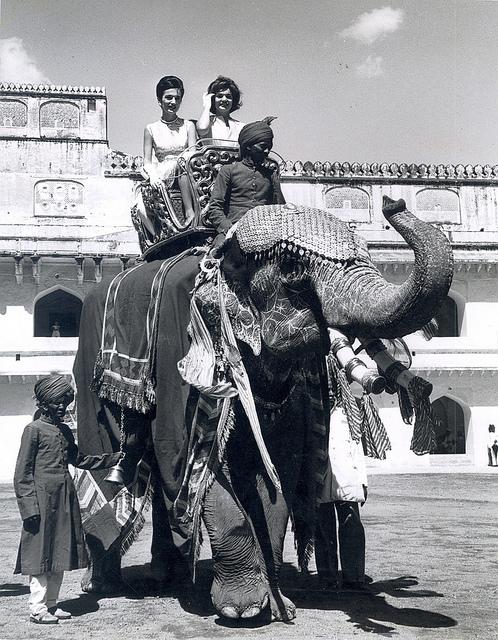What is on the elephant's head?
Give a very brief answer. Hat. Was this taken in the United States?
Answer briefly. No. Are the women on the elephant tourists?
Keep it brief. Yes. 